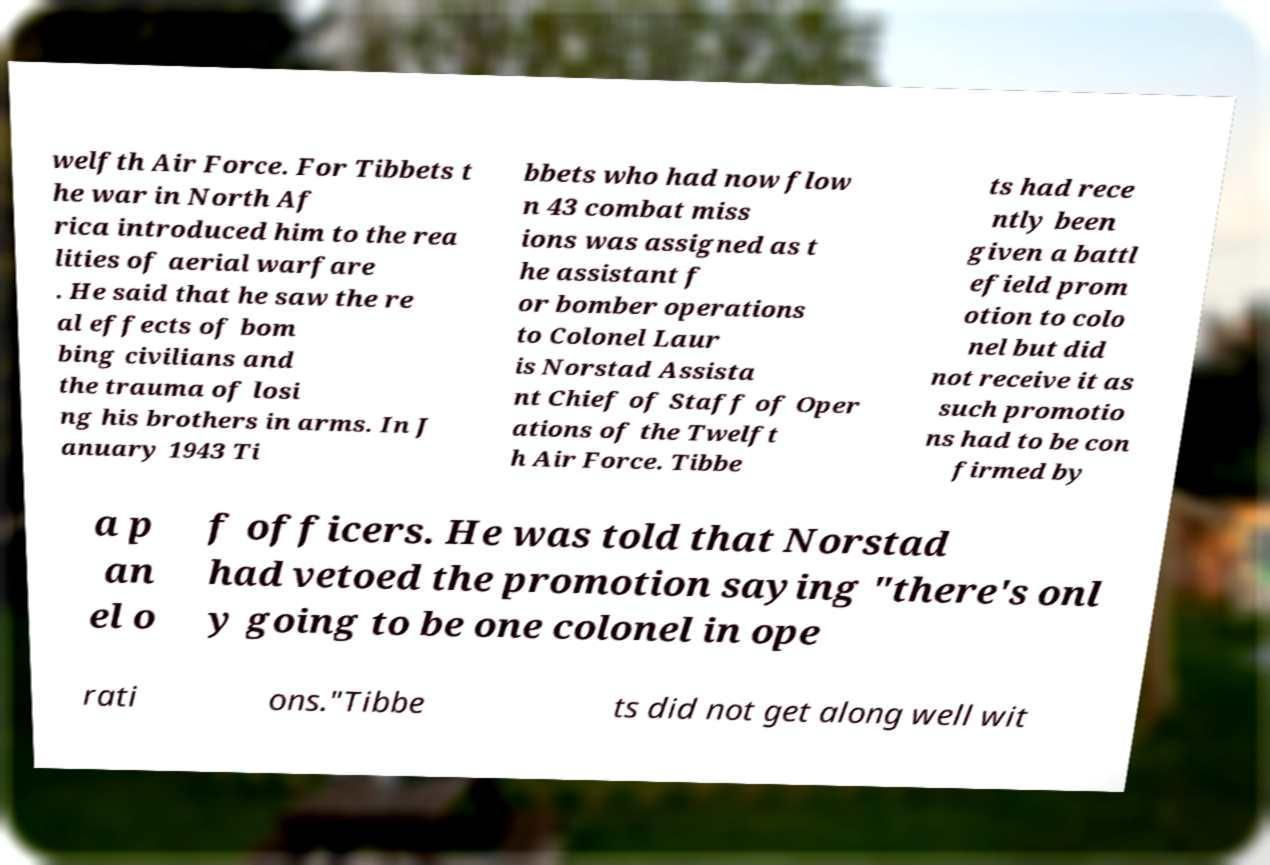Could you extract and type out the text from this image? welfth Air Force. For Tibbets t he war in North Af rica introduced him to the rea lities of aerial warfare . He said that he saw the re al effects of bom bing civilians and the trauma of losi ng his brothers in arms. In J anuary 1943 Ti bbets who had now flow n 43 combat miss ions was assigned as t he assistant f or bomber operations to Colonel Laur is Norstad Assista nt Chief of Staff of Oper ations of the Twelft h Air Force. Tibbe ts had rece ntly been given a battl efield prom otion to colo nel but did not receive it as such promotio ns had to be con firmed by a p an el o f officers. He was told that Norstad had vetoed the promotion saying "there's onl y going to be one colonel in ope rati ons."Tibbe ts did not get along well wit 